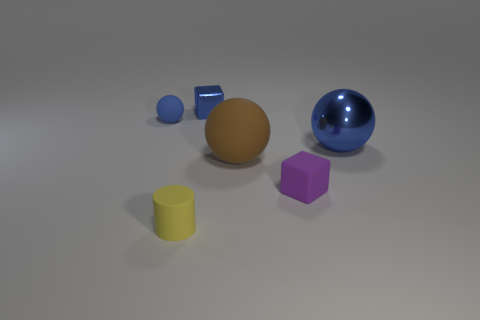What number of blue matte objects are the same size as the brown thing?
Offer a very short reply. 0. What size is the block that is the same material as the yellow thing?
Your answer should be compact. Small. What number of small shiny objects are the same shape as the brown matte object?
Make the answer very short. 0. How many brown metallic spheres are there?
Offer a very short reply. 0. Do the blue shiny thing to the right of the matte cube and the small purple thing have the same shape?
Give a very brief answer. No. There is a blue ball that is the same size as the yellow rubber cylinder; what material is it?
Make the answer very short. Rubber. Is there a tiny yellow ball that has the same material as the large blue thing?
Your response must be concise. No. There is a small yellow matte object; is it the same shape as the tiny object on the right side of the shiny block?
Offer a very short reply. No. What number of things are both in front of the big matte sphere and on the right side of the yellow object?
Keep it short and to the point. 1. Do the blue block and the blue object that is left of the yellow cylinder have the same material?
Provide a succinct answer. No. 